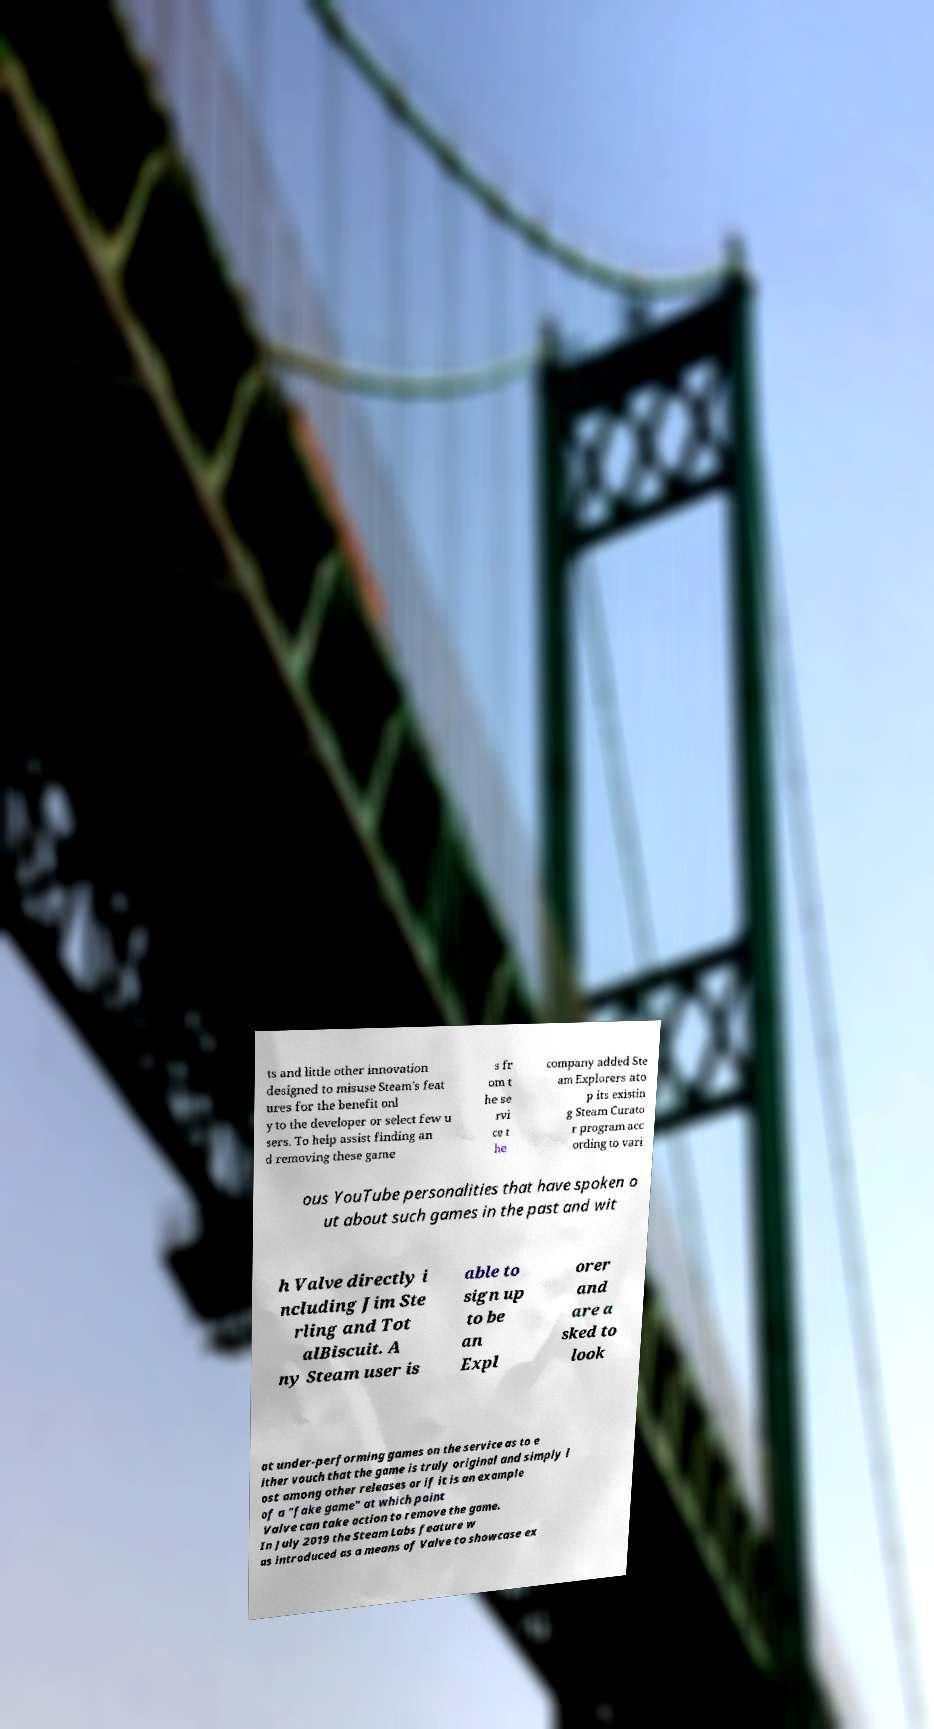Could you assist in decoding the text presented in this image and type it out clearly? ts and little other innovation designed to misuse Steam's feat ures for the benefit onl y to the developer or select few u sers. To help assist finding an d removing these game s fr om t he se rvi ce t he company added Ste am Explorers ato p its existin g Steam Curato r program acc ording to vari ous YouTube personalities that have spoken o ut about such games in the past and wit h Valve directly i ncluding Jim Ste rling and Tot alBiscuit. A ny Steam user is able to sign up to be an Expl orer and are a sked to look at under-performing games on the service as to e ither vouch that the game is truly original and simply l ost among other releases or if it is an example of a "fake game" at which point Valve can take action to remove the game. In July 2019 the Steam Labs feature w as introduced as a means of Valve to showcase ex 